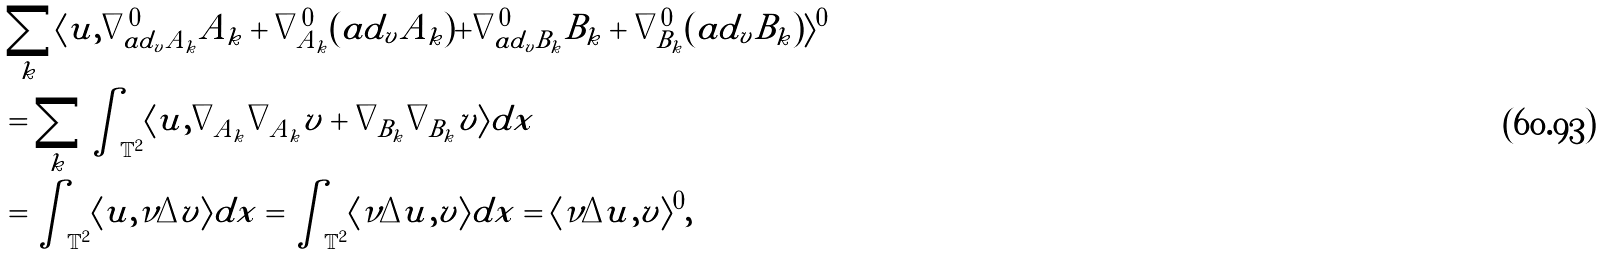Convert formula to latex. <formula><loc_0><loc_0><loc_500><loc_500>& \sum _ { k } \langle u , \nabla ^ { 0 } _ { a d _ { v } A _ { k } } A _ { k } + \nabla ^ { 0 } _ { A _ { k } } ( a d _ { v } A _ { k } ) + \nabla ^ { 0 } _ { a d _ { v } B _ { k } } B _ { k } + \nabla ^ { 0 } _ { B _ { k } } ( a d _ { v } B _ { k } ) \rangle ^ { 0 } \\ & = \sum _ { k } \int _ { \mathbb { T } ^ { 2 } } \langle u , \nabla _ { A _ { k } } \nabla _ { A _ { k } } v + \nabla _ { B _ { k } } \nabla _ { B _ { k } } v \rangle d x \\ & = \int _ { \mathbb { T } ^ { 2 } } \langle u , \nu \Delta v \rangle d x = \int _ { \mathbb { T } ^ { 2 } } \langle \nu \Delta u , v \rangle d x = \langle \nu \Delta u , v \rangle ^ { 0 } ,</formula> 